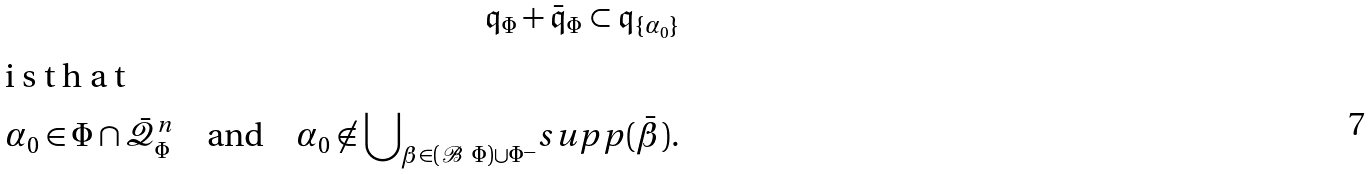Convert formula to latex. <formula><loc_0><loc_0><loc_500><loc_500>\mathfrak { q } _ { \Phi } + \bar { \mathfrak { q } } _ { \Phi } \subset \mathfrak { q } _ { \{ \alpha _ { 0 } \} } \intertext { i s t h a t } \alpha _ { 0 } \in \Phi \cap \bar { \mathcal { Q } } ^ { n } _ { \Phi } \quad \text {and} \quad \alpha _ { 0 } \not \in { \bigcup } _ { \beta \in ( \mathcal { B } \ \Phi ) \cup \Phi ^ { - } } s u p p ( \bar { \beta } ) .</formula> 